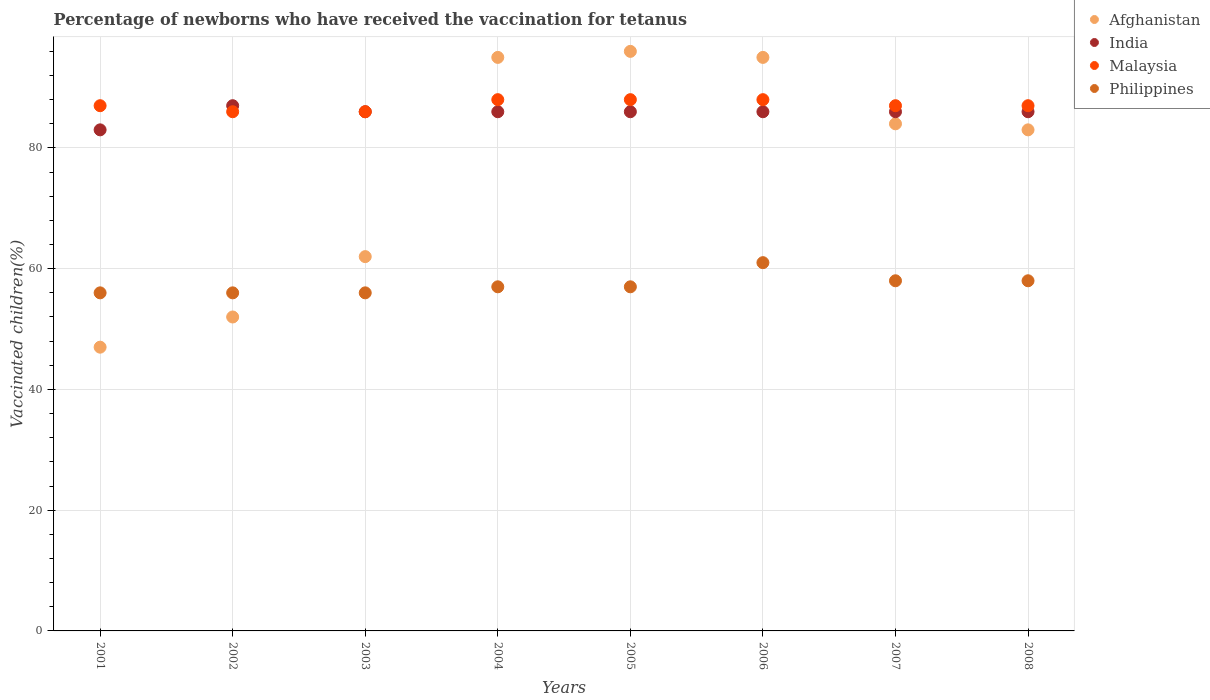Is the number of dotlines equal to the number of legend labels?
Provide a succinct answer. Yes. What is the percentage of vaccinated children in Afghanistan in 2007?
Offer a very short reply. 84. Across all years, what is the maximum percentage of vaccinated children in India?
Make the answer very short. 87. Across all years, what is the minimum percentage of vaccinated children in Philippines?
Ensure brevity in your answer.  56. In which year was the percentage of vaccinated children in India maximum?
Provide a short and direct response. 2002. In which year was the percentage of vaccinated children in Philippines minimum?
Your response must be concise. 2001. What is the total percentage of vaccinated children in Philippines in the graph?
Ensure brevity in your answer.  459. What is the difference between the percentage of vaccinated children in Afghanistan in 2003 and that in 2005?
Make the answer very short. -34. What is the difference between the percentage of vaccinated children in Afghanistan in 2006 and the percentage of vaccinated children in India in 2004?
Your answer should be compact. 9. What is the average percentage of vaccinated children in Afghanistan per year?
Provide a short and direct response. 76.75. In the year 2007, what is the difference between the percentage of vaccinated children in India and percentage of vaccinated children in Malaysia?
Make the answer very short. -1. In how many years, is the percentage of vaccinated children in India greater than 4 %?
Provide a short and direct response. 8. Is the percentage of vaccinated children in India in 2003 less than that in 2004?
Provide a succinct answer. No. What is the difference between the highest and the lowest percentage of vaccinated children in Philippines?
Your answer should be compact. 5. In how many years, is the percentage of vaccinated children in Afghanistan greater than the average percentage of vaccinated children in Afghanistan taken over all years?
Keep it short and to the point. 5. Is it the case that in every year, the sum of the percentage of vaccinated children in India and percentage of vaccinated children in Afghanistan  is greater than the sum of percentage of vaccinated children in Malaysia and percentage of vaccinated children in Philippines?
Keep it short and to the point. No. Is the percentage of vaccinated children in Afghanistan strictly greater than the percentage of vaccinated children in Philippines over the years?
Your answer should be very brief. No. How many dotlines are there?
Your answer should be compact. 4. How many years are there in the graph?
Provide a short and direct response. 8. Are the values on the major ticks of Y-axis written in scientific E-notation?
Give a very brief answer. No. Does the graph contain grids?
Make the answer very short. Yes. Where does the legend appear in the graph?
Keep it short and to the point. Top right. How many legend labels are there?
Offer a very short reply. 4. How are the legend labels stacked?
Your answer should be compact. Vertical. What is the title of the graph?
Ensure brevity in your answer.  Percentage of newborns who have received the vaccination for tetanus. Does "Liechtenstein" appear as one of the legend labels in the graph?
Ensure brevity in your answer.  No. What is the label or title of the Y-axis?
Offer a very short reply. Vaccinated children(%). What is the Vaccinated children(%) of Malaysia in 2001?
Give a very brief answer. 87. What is the Vaccinated children(%) of Afghanistan in 2002?
Give a very brief answer. 52. What is the Vaccinated children(%) in India in 2002?
Provide a short and direct response. 87. What is the Vaccinated children(%) of Malaysia in 2002?
Your answer should be compact. 86. What is the Vaccinated children(%) in Philippines in 2002?
Give a very brief answer. 56. What is the Vaccinated children(%) of India in 2003?
Your answer should be very brief. 86. What is the Vaccinated children(%) in Malaysia in 2003?
Offer a very short reply. 86. What is the Vaccinated children(%) in Malaysia in 2004?
Provide a short and direct response. 88. What is the Vaccinated children(%) of Afghanistan in 2005?
Ensure brevity in your answer.  96. What is the Vaccinated children(%) in Malaysia in 2005?
Give a very brief answer. 88. What is the Vaccinated children(%) of Philippines in 2005?
Offer a very short reply. 57. What is the Vaccinated children(%) of Afghanistan in 2006?
Make the answer very short. 95. What is the Vaccinated children(%) in Malaysia in 2006?
Ensure brevity in your answer.  88. What is the Vaccinated children(%) in India in 2007?
Offer a very short reply. 86. What is the Vaccinated children(%) in Philippines in 2007?
Your response must be concise. 58. What is the Vaccinated children(%) in Afghanistan in 2008?
Give a very brief answer. 83. What is the Vaccinated children(%) of Malaysia in 2008?
Provide a succinct answer. 87. What is the Vaccinated children(%) in Philippines in 2008?
Your response must be concise. 58. Across all years, what is the maximum Vaccinated children(%) in Afghanistan?
Your response must be concise. 96. Across all years, what is the minimum Vaccinated children(%) of Afghanistan?
Ensure brevity in your answer.  47. Across all years, what is the minimum Vaccinated children(%) of India?
Ensure brevity in your answer.  83. Across all years, what is the minimum Vaccinated children(%) in Philippines?
Offer a terse response. 56. What is the total Vaccinated children(%) in Afghanistan in the graph?
Provide a succinct answer. 614. What is the total Vaccinated children(%) in India in the graph?
Your answer should be compact. 686. What is the total Vaccinated children(%) of Malaysia in the graph?
Make the answer very short. 697. What is the total Vaccinated children(%) in Philippines in the graph?
Give a very brief answer. 459. What is the difference between the Vaccinated children(%) of Philippines in 2001 and that in 2002?
Your answer should be very brief. 0. What is the difference between the Vaccinated children(%) of India in 2001 and that in 2003?
Offer a very short reply. -3. What is the difference between the Vaccinated children(%) in Malaysia in 2001 and that in 2003?
Make the answer very short. 1. What is the difference between the Vaccinated children(%) of Philippines in 2001 and that in 2003?
Ensure brevity in your answer.  0. What is the difference between the Vaccinated children(%) of Afghanistan in 2001 and that in 2004?
Ensure brevity in your answer.  -48. What is the difference between the Vaccinated children(%) of Malaysia in 2001 and that in 2004?
Your answer should be very brief. -1. What is the difference between the Vaccinated children(%) in Afghanistan in 2001 and that in 2005?
Offer a terse response. -49. What is the difference between the Vaccinated children(%) of Malaysia in 2001 and that in 2005?
Give a very brief answer. -1. What is the difference between the Vaccinated children(%) of Philippines in 2001 and that in 2005?
Ensure brevity in your answer.  -1. What is the difference between the Vaccinated children(%) in Afghanistan in 2001 and that in 2006?
Provide a short and direct response. -48. What is the difference between the Vaccinated children(%) in Afghanistan in 2001 and that in 2007?
Provide a short and direct response. -37. What is the difference between the Vaccinated children(%) in India in 2001 and that in 2007?
Provide a short and direct response. -3. What is the difference between the Vaccinated children(%) of Malaysia in 2001 and that in 2007?
Ensure brevity in your answer.  0. What is the difference between the Vaccinated children(%) in Afghanistan in 2001 and that in 2008?
Keep it short and to the point. -36. What is the difference between the Vaccinated children(%) in India in 2001 and that in 2008?
Your response must be concise. -3. What is the difference between the Vaccinated children(%) of India in 2002 and that in 2003?
Offer a terse response. 1. What is the difference between the Vaccinated children(%) in Malaysia in 2002 and that in 2003?
Provide a short and direct response. 0. What is the difference between the Vaccinated children(%) in Philippines in 2002 and that in 2003?
Give a very brief answer. 0. What is the difference between the Vaccinated children(%) of Afghanistan in 2002 and that in 2004?
Your response must be concise. -43. What is the difference between the Vaccinated children(%) in India in 2002 and that in 2004?
Your answer should be very brief. 1. What is the difference between the Vaccinated children(%) of Malaysia in 2002 and that in 2004?
Offer a terse response. -2. What is the difference between the Vaccinated children(%) in Philippines in 2002 and that in 2004?
Provide a short and direct response. -1. What is the difference between the Vaccinated children(%) in Afghanistan in 2002 and that in 2005?
Your answer should be compact. -44. What is the difference between the Vaccinated children(%) of India in 2002 and that in 2005?
Give a very brief answer. 1. What is the difference between the Vaccinated children(%) in Afghanistan in 2002 and that in 2006?
Your response must be concise. -43. What is the difference between the Vaccinated children(%) in India in 2002 and that in 2006?
Provide a succinct answer. 1. What is the difference between the Vaccinated children(%) in Malaysia in 2002 and that in 2006?
Your answer should be compact. -2. What is the difference between the Vaccinated children(%) of Afghanistan in 2002 and that in 2007?
Your answer should be compact. -32. What is the difference between the Vaccinated children(%) in India in 2002 and that in 2007?
Keep it short and to the point. 1. What is the difference between the Vaccinated children(%) in Afghanistan in 2002 and that in 2008?
Make the answer very short. -31. What is the difference between the Vaccinated children(%) in India in 2002 and that in 2008?
Offer a very short reply. 1. What is the difference between the Vaccinated children(%) in Afghanistan in 2003 and that in 2004?
Make the answer very short. -33. What is the difference between the Vaccinated children(%) of Philippines in 2003 and that in 2004?
Give a very brief answer. -1. What is the difference between the Vaccinated children(%) in Afghanistan in 2003 and that in 2005?
Provide a short and direct response. -34. What is the difference between the Vaccinated children(%) in Malaysia in 2003 and that in 2005?
Ensure brevity in your answer.  -2. What is the difference between the Vaccinated children(%) of Afghanistan in 2003 and that in 2006?
Your response must be concise. -33. What is the difference between the Vaccinated children(%) in Malaysia in 2003 and that in 2006?
Give a very brief answer. -2. What is the difference between the Vaccinated children(%) of Philippines in 2003 and that in 2006?
Provide a succinct answer. -5. What is the difference between the Vaccinated children(%) of India in 2003 and that in 2007?
Offer a very short reply. 0. What is the difference between the Vaccinated children(%) of Malaysia in 2003 and that in 2007?
Your response must be concise. -1. What is the difference between the Vaccinated children(%) of Philippines in 2003 and that in 2007?
Keep it short and to the point. -2. What is the difference between the Vaccinated children(%) of Afghanistan in 2003 and that in 2008?
Make the answer very short. -21. What is the difference between the Vaccinated children(%) of Philippines in 2003 and that in 2008?
Ensure brevity in your answer.  -2. What is the difference between the Vaccinated children(%) of Malaysia in 2004 and that in 2005?
Offer a terse response. 0. What is the difference between the Vaccinated children(%) of India in 2004 and that in 2006?
Offer a terse response. 0. What is the difference between the Vaccinated children(%) of Afghanistan in 2004 and that in 2007?
Your answer should be compact. 11. What is the difference between the Vaccinated children(%) of Malaysia in 2004 and that in 2007?
Provide a succinct answer. 1. What is the difference between the Vaccinated children(%) of Philippines in 2004 and that in 2007?
Provide a short and direct response. -1. What is the difference between the Vaccinated children(%) of Afghanistan in 2004 and that in 2008?
Make the answer very short. 12. What is the difference between the Vaccinated children(%) in India in 2004 and that in 2008?
Offer a terse response. 0. What is the difference between the Vaccinated children(%) in Philippines in 2004 and that in 2008?
Provide a short and direct response. -1. What is the difference between the Vaccinated children(%) of India in 2005 and that in 2006?
Offer a terse response. 0. What is the difference between the Vaccinated children(%) in Malaysia in 2005 and that in 2006?
Keep it short and to the point. 0. What is the difference between the Vaccinated children(%) of Afghanistan in 2005 and that in 2007?
Keep it short and to the point. 12. What is the difference between the Vaccinated children(%) in India in 2005 and that in 2007?
Offer a very short reply. 0. What is the difference between the Vaccinated children(%) in Philippines in 2005 and that in 2007?
Your response must be concise. -1. What is the difference between the Vaccinated children(%) in Afghanistan in 2005 and that in 2008?
Your response must be concise. 13. What is the difference between the Vaccinated children(%) of India in 2005 and that in 2008?
Ensure brevity in your answer.  0. What is the difference between the Vaccinated children(%) of Malaysia in 2005 and that in 2008?
Offer a terse response. 1. What is the difference between the Vaccinated children(%) of Afghanistan in 2006 and that in 2008?
Give a very brief answer. 12. What is the difference between the Vaccinated children(%) in India in 2006 and that in 2008?
Your answer should be very brief. 0. What is the difference between the Vaccinated children(%) in Malaysia in 2006 and that in 2008?
Ensure brevity in your answer.  1. What is the difference between the Vaccinated children(%) in Philippines in 2006 and that in 2008?
Your answer should be very brief. 3. What is the difference between the Vaccinated children(%) in Afghanistan in 2007 and that in 2008?
Make the answer very short. 1. What is the difference between the Vaccinated children(%) of India in 2007 and that in 2008?
Your response must be concise. 0. What is the difference between the Vaccinated children(%) in Malaysia in 2007 and that in 2008?
Ensure brevity in your answer.  0. What is the difference between the Vaccinated children(%) of Philippines in 2007 and that in 2008?
Your answer should be compact. 0. What is the difference between the Vaccinated children(%) of Afghanistan in 2001 and the Vaccinated children(%) of Malaysia in 2002?
Provide a succinct answer. -39. What is the difference between the Vaccinated children(%) of Afghanistan in 2001 and the Vaccinated children(%) of Philippines in 2002?
Keep it short and to the point. -9. What is the difference between the Vaccinated children(%) of Afghanistan in 2001 and the Vaccinated children(%) of India in 2003?
Offer a very short reply. -39. What is the difference between the Vaccinated children(%) in Afghanistan in 2001 and the Vaccinated children(%) in Malaysia in 2003?
Keep it short and to the point. -39. What is the difference between the Vaccinated children(%) in Afghanistan in 2001 and the Vaccinated children(%) in Philippines in 2003?
Ensure brevity in your answer.  -9. What is the difference between the Vaccinated children(%) in India in 2001 and the Vaccinated children(%) in Malaysia in 2003?
Give a very brief answer. -3. What is the difference between the Vaccinated children(%) in Malaysia in 2001 and the Vaccinated children(%) in Philippines in 2003?
Provide a succinct answer. 31. What is the difference between the Vaccinated children(%) in Afghanistan in 2001 and the Vaccinated children(%) in India in 2004?
Provide a succinct answer. -39. What is the difference between the Vaccinated children(%) in Afghanistan in 2001 and the Vaccinated children(%) in Malaysia in 2004?
Offer a very short reply. -41. What is the difference between the Vaccinated children(%) in Afghanistan in 2001 and the Vaccinated children(%) in Philippines in 2004?
Offer a very short reply. -10. What is the difference between the Vaccinated children(%) of India in 2001 and the Vaccinated children(%) of Malaysia in 2004?
Make the answer very short. -5. What is the difference between the Vaccinated children(%) in India in 2001 and the Vaccinated children(%) in Philippines in 2004?
Make the answer very short. 26. What is the difference between the Vaccinated children(%) in Afghanistan in 2001 and the Vaccinated children(%) in India in 2005?
Ensure brevity in your answer.  -39. What is the difference between the Vaccinated children(%) in Afghanistan in 2001 and the Vaccinated children(%) in Malaysia in 2005?
Ensure brevity in your answer.  -41. What is the difference between the Vaccinated children(%) in Malaysia in 2001 and the Vaccinated children(%) in Philippines in 2005?
Your answer should be compact. 30. What is the difference between the Vaccinated children(%) of Afghanistan in 2001 and the Vaccinated children(%) of India in 2006?
Provide a short and direct response. -39. What is the difference between the Vaccinated children(%) in Afghanistan in 2001 and the Vaccinated children(%) in Malaysia in 2006?
Give a very brief answer. -41. What is the difference between the Vaccinated children(%) of India in 2001 and the Vaccinated children(%) of Philippines in 2006?
Ensure brevity in your answer.  22. What is the difference between the Vaccinated children(%) of Afghanistan in 2001 and the Vaccinated children(%) of India in 2007?
Ensure brevity in your answer.  -39. What is the difference between the Vaccinated children(%) of Malaysia in 2001 and the Vaccinated children(%) of Philippines in 2007?
Your response must be concise. 29. What is the difference between the Vaccinated children(%) in Afghanistan in 2001 and the Vaccinated children(%) in India in 2008?
Your answer should be compact. -39. What is the difference between the Vaccinated children(%) of Afghanistan in 2001 and the Vaccinated children(%) of Malaysia in 2008?
Make the answer very short. -40. What is the difference between the Vaccinated children(%) of Afghanistan in 2001 and the Vaccinated children(%) of Philippines in 2008?
Offer a very short reply. -11. What is the difference between the Vaccinated children(%) of India in 2001 and the Vaccinated children(%) of Philippines in 2008?
Offer a terse response. 25. What is the difference between the Vaccinated children(%) in Malaysia in 2001 and the Vaccinated children(%) in Philippines in 2008?
Give a very brief answer. 29. What is the difference between the Vaccinated children(%) of Afghanistan in 2002 and the Vaccinated children(%) of India in 2003?
Offer a terse response. -34. What is the difference between the Vaccinated children(%) of Afghanistan in 2002 and the Vaccinated children(%) of Malaysia in 2003?
Your answer should be very brief. -34. What is the difference between the Vaccinated children(%) of Afghanistan in 2002 and the Vaccinated children(%) of Philippines in 2003?
Offer a very short reply. -4. What is the difference between the Vaccinated children(%) of India in 2002 and the Vaccinated children(%) of Philippines in 2003?
Ensure brevity in your answer.  31. What is the difference between the Vaccinated children(%) in Afghanistan in 2002 and the Vaccinated children(%) in India in 2004?
Keep it short and to the point. -34. What is the difference between the Vaccinated children(%) of Afghanistan in 2002 and the Vaccinated children(%) of Malaysia in 2004?
Your answer should be very brief. -36. What is the difference between the Vaccinated children(%) of India in 2002 and the Vaccinated children(%) of Malaysia in 2004?
Keep it short and to the point. -1. What is the difference between the Vaccinated children(%) in Malaysia in 2002 and the Vaccinated children(%) in Philippines in 2004?
Provide a short and direct response. 29. What is the difference between the Vaccinated children(%) of Afghanistan in 2002 and the Vaccinated children(%) of India in 2005?
Provide a short and direct response. -34. What is the difference between the Vaccinated children(%) in Afghanistan in 2002 and the Vaccinated children(%) in Malaysia in 2005?
Your answer should be very brief. -36. What is the difference between the Vaccinated children(%) of India in 2002 and the Vaccinated children(%) of Malaysia in 2005?
Offer a very short reply. -1. What is the difference between the Vaccinated children(%) in India in 2002 and the Vaccinated children(%) in Philippines in 2005?
Provide a short and direct response. 30. What is the difference between the Vaccinated children(%) in Afghanistan in 2002 and the Vaccinated children(%) in India in 2006?
Provide a succinct answer. -34. What is the difference between the Vaccinated children(%) of Afghanistan in 2002 and the Vaccinated children(%) of Malaysia in 2006?
Make the answer very short. -36. What is the difference between the Vaccinated children(%) of Afghanistan in 2002 and the Vaccinated children(%) of India in 2007?
Offer a very short reply. -34. What is the difference between the Vaccinated children(%) of Afghanistan in 2002 and the Vaccinated children(%) of Malaysia in 2007?
Your answer should be compact. -35. What is the difference between the Vaccinated children(%) in Afghanistan in 2002 and the Vaccinated children(%) in Philippines in 2007?
Provide a short and direct response. -6. What is the difference between the Vaccinated children(%) of Malaysia in 2002 and the Vaccinated children(%) of Philippines in 2007?
Make the answer very short. 28. What is the difference between the Vaccinated children(%) of Afghanistan in 2002 and the Vaccinated children(%) of India in 2008?
Make the answer very short. -34. What is the difference between the Vaccinated children(%) of Afghanistan in 2002 and the Vaccinated children(%) of Malaysia in 2008?
Your answer should be compact. -35. What is the difference between the Vaccinated children(%) in India in 2002 and the Vaccinated children(%) in Malaysia in 2008?
Provide a succinct answer. 0. What is the difference between the Vaccinated children(%) of India in 2002 and the Vaccinated children(%) of Philippines in 2008?
Ensure brevity in your answer.  29. What is the difference between the Vaccinated children(%) in Afghanistan in 2003 and the Vaccinated children(%) in Philippines in 2004?
Ensure brevity in your answer.  5. What is the difference between the Vaccinated children(%) of Afghanistan in 2003 and the Vaccinated children(%) of Malaysia in 2005?
Offer a terse response. -26. What is the difference between the Vaccinated children(%) in Afghanistan in 2003 and the Vaccinated children(%) in Philippines in 2005?
Offer a terse response. 5. What is the difference between the Vaccinated children(%) in India in 2003 and the Vaccinated children(%) in Philippines in 2005?
Keep it short and to the point. 29. What is the difference between the Vaccinated children(%) in Afghanistan in 2003 and the Vaccinated children(%) in Malaysia in 2006?
Provide a succinct answer. -26. What is the difference between the Vaccinated children(%) in Afghanistan in 2003 and the Vaccinated children(%) in Philippines in 2007?
Provide a short and direct response. 4. What is the difference between the Vaccinated children(%) of India in 2003 and the Vaccinated children(%) of Malaysia in 2007?
Provide a succinct answer. -1. What is the difference between the Vaccinated children(%) of Afghanistan in 2003 and the Vaccinated children(%) of India in 2008?
Keep it short and to the point. -24. What is the difference between the Vaccinated children(%) in Afghanistan in 2003 and the Vaccinated children(%) in Philippines in 2008?
Provide a short and direct response. 4. What is the difference between the Vaccinated children(%) in India in 2003 and the Vaccinated children(%) in Philippines in 2008?
Keep it short and to the point. 28. What is the difference between the Vaccinated children(%) of Malaysia in 2003 and the Vaccinated children(%) of Philippines in 2008?
Your answer should be very brief. 28. What is the difference between the Vaccinated children(%) in Afghanistan in 2004 and the Vaccinated children(%) in India in 2005?
Your answer should be compact. 9. What is the difference between the Vaccinated children(%) of Afghanistan in 2004 and the Vaccinated children(%) of Philippines in 2005?
Your answer should be very brief. 38. What is the difference between the Vaccinated children(%) of India in 2004 and the Vaccinated children(%) of Malaysia in 2005?
Keep it short and to the point. -2. What is the difference between the Vaccinated children(%) of India in 2004 and the Vaccinated children(%) of Philippines in 2005?
Offer a terse response. 29. What is the difference between the Vaccinated children(%) of Malaysia in 2004 and the Vaccinated children(%) of Philippines in 2005?
Ensure brevity in your answer.  31. What is the difference between the Vaccinated children(%) of Afghanistan in 2004 and the Vaccinated children(%) of India in 2006?
Your response must be concise. 9. What is the difference between the Vaccinated children(%) in Afghanistan in 2004 and the Vaccinated children(%) in Malaysia in 2006?
Your answer should be compact. 7. What is the difference between the Vaccinated children(%) of India in 2004 and the Vaccinated children(%) of Malaysia in 2006?
Keep it short and to the point. -2. What is the difference between the Vaccinated children(%) in Afghanistan in 2004 and the Vaccinated children(%) in India in 2007?
Your answer should be very brief. 9. What is the difference between the Vaccinated children(%) in Afghanistan in 2004 and the Vaccinated children(%) in Malaysia in 2007?
Provide a short and direct response. 8. What is the difference between the Vaccinated children(%) in Afghanistan in 2004 and the Vaccinated children(%) in Malaysia in 2008?
Your answer should be compact. 8. What is the difference between the Vaccinated children(%) of India in 2004 and the Vaccinated children(%) of Malaysia in 2008?
Offer a very short reply. -1. What is the difference between the Vaccinated children(%) in Malaysia in 2004 and the Vaccinated children(%) in Philippines in 2008?
Offer a terse response. 30. What is the difference between the Vaccinated children(%) in Afghanistan in 2005 and the Vaccinated children(%) in Malaysia in 2006?
Offer a very short reply. 8. What is the difference between the Vaccinated children(%) in Afghanistan in 2005 and the Vaccinated children(%) in Philippines in 2006?
Provide a short and direct response. 35. What is the difference between the Vaccinated children(%) of India in 2005 and the Vaccinated children(%) of Malaysia in 2006?
Make the answer very short. -2. What is the difference between the Vaccinated children(%) of India in 2005 and the Vaccinated children(%) of Philippines in 2006?
Make the answer very short. 25. What is the difference between the Vaccinated children(%) of Afghanistan in 2005 and the Vaccinated children(%) of India in 2007?
Give a very brief answer. 10. What is the difference between the Vaccinated children(%) in Afghanistan in 2005 and the Vaccinated children(%) in Malaysia in 2007?
Provide a succinct answer. 9. What is the difference between the Vaccinated children(%) in India in 2005 and the Vaccinated children(%) in Malaysia in 2007?
Keep it short and to the point. -1. What is the difference between the Vaccinated children(%) in Malaysia in 2005 and the Vaccinated children(%) in Philippines in 2007?
Offer a very short reply. 30. What is the difference between the Vaccinated children(%) in Afghanistan in 2005 and the Vaccinated children(%) in Malaysia in 2008?
Offer a very short reply. 9. What is the difference between the Vaccinated children(%) of Afghanistan in 2005 and the Vaccinated children(%) of Philippines in 2008?
Make the answer very short. 38. What is the difference between the Vaccinated children(%) in Afghanistan in 2006 and the Vaccinated children(%) in India in 2007?
Ensure brevity in your answer.  9. What is the difference between the Vaccinated children(%) of Afghanistan in 2006 and the Vaccinated children(%) of Malaysia in 2007?
Your answer should be very brief. 8. What is the difference between the Vaccinated children(%) of Afghanistan in 2006 and the Vaccinated children(%) of India in 2008?
Keep it short and to the point. 9. What is the difference between the Vaccinated children(%) of Afghanistan in 2006 and the Vaccinated children(%) of Philippines in 2008?
Offer a very short reply. 37. What is the difference between the Vaccinated children(%) in India in 2006 and the Vaccinated children(%) in Malaysia in 2008?
Provide a succinct answer. -1. What is the difference between the Vaccinated children(%) in Malaysia in 2006 and the Vaccinated children(%) in Philippines in 2008?
Your answer should be very brief. 30. What is the difference between the Vaccinated children(%) of Afghanistan in 2007 and the Vaccinated children(%) of Malaysia in 2008?
Offer a very short reply. -3. What is the difference between the Vaccinated children(%) of Afghanistan in 2007 and the Vaccinated children(%) of Philippines in 2008?
Offer a terse response. 26. What is the difference between the Vaccinated children(%) in Malaysia in 2007 and the Vaccinated children(%) in Philippines in 2008?
Your answer should be very brief. 29. What is the average Vaccinated children(%) in Afghanistan per year?
Your answer should be compact. 76.75. What is the average Vaccinated children(%) in India per year?
Provide a short and direct response. 85.75. What is the average Vaccinated children(%) of Malaysia per year?
Your answer should be very brief. 87.12. What is the average Vaccinated children(%) in Philippines per year?
Ensure brevity in your answer.  57.38. In the year 2001, what is the difference between the Vaccinated children(%) of Afghanistan and Vaccinated children(%) of India?
Ensure brevity in your answer.  -36. In the year 2001, what is the difference between the Vaccinated children(%) in India and Vaccinated children(%) in Malaysia?
Make the answer very short. -4. In the year 2001, what is the difference between the Vaccinated children(%) in India and Vaccinated children(%) in Philippines?
Make the answer very short. 27. In the year 2002, what is the difference between the Vaccinated children(%) in Afghanistan and Vaccinated children(%) in India?
Make the answer very short. -35. In the year 2002, what is the difference between the Vaccinated children(%) of Afghanistan and Vaccinated children(%) of Malaysia?
Provide a succinct answer. -34. In the year 2002, what is the difference between the Vaccinated children(%) in India and Vaccinated children(%) in Malaysia?
Provide a succinct answer. 1. In the year 2003, what is the difference between the Vaccinated children(%) of India and Vaccinated children(%) of Philippines?
Your answer should be very brief. 30. In the year 2004, what is the difference between the Vaccinated children(%) in Malaysia and Vaccinated children(%) in Philippines?
Your answer should be compact. 31. In the year 2005, what is the difference between the Vaccinated children(%) in Afghanistan and Vaccinated children(%) in Malaysia?
Provide a succinct answer. 8. In the year 2005, what is the difference between the Vaccinated children(%) in Afghanistan and Vaccinated children(%) in Philippines?
Make the answer very short. 39. In the year 2005, what is the difference between the Vaccinated children(%) of India and Vaccinated children(%) of Malaysia?
Provide a short and direct response. -2. In the year 2005, what is the difference between the Vaccinated children(%) in India and Vaccinated children(%) in Philippines?
Ensure brevity in your answer.  29. In the year 2006, what is the difference between the Vaccinated children(%) in Afghanistan and Vaccinated children(%) in Malaysia?
Your response must be concise. 7. In the year 2006, what is the difference between the Vaccinated children(%) of India and Vaccinated children(%) of Malaysia?
Your answer should be compact. -2. In the year 2007, what is the difference between the Vaccinated children(%) of Afghanistan and Vaccinated children(%) of Malaysia?
Provide a short and direct response. -3. In the year 2007, what is the difference between the Vaccinated children(%) in India and Vaccinated children(%) in Philippines?
Your response must be concise. 28. In the year 2008, what is the difference between the Vaccinated children(%) in Afghanistan and Vaccinated children(%) in India?
Make the answer very short. -3. In the year 2008, what is the difference between the Vaccinated children(%) in Afghanistan and Vaccinated children(%) in Malaysia?
Offer a terse response. -4. In the year 2008, what is the difference between the Vaccinated children(%) in India and Vaccinated children(%) in Philippines?
Offer a very short reply. 28. In the year 2008, what is the difference between the Vaccinated children(%) in Malaysia and Vaccinated children(%) in Philippines?
Provide a succinct answer. 29. What is the ratio of the Vaccinated children(%) of Afghanistan in 2001 to that in 2002?
Provide a short and direct response. 0.9. What is the ratio of the Vaccinated children(%) of India in 2001 to that in 2002?
Keep it short and to the point. 0.95. What is the ratio of the Vaccinated children(%) of Malaysia in 2001 to that in 2002?
Ensure brevity in your answer.  1.01. What is the ratio of the Vaccinated children(%) in Philippines in 2001 to that in 2002?
Your answer should be very brief. 1. What is the ratio of the Vaccinated children(%) in Afghanistan in 2001 to that in 2003?
Ensure brevity in your answer.  0.76. What is the ratio of the Vaccinated children(%) of India in 2001 to that in 2003?
Your answer should be very brief. 0.97. What is the ratio of the Vaccinated children(%) of Malaysia in 2001 to that in 2003?
Ensure brevity in your answer.  1.01. What is the ratio of the Vaccinated children(%) in Afghanistan in 2001 to that in 2004?
Provide a succinct answer. 0.49. What is the ratio of the Vaccinated children(%) in India in 2001 to that in 2004?
Offer a very short reply. 0.97. What is the ratio of the Vaccinated children(%) in Malaysia in 2001 to that in 2004?
Keep it short and to the point. 0.99. What is the ratio of the Vaccinated children(%) in Philippines in 2001 to that in 2004?
Keep it short and to the point. 0.98. What is the ratio of the Vaccinated children(%) of Afghanistan in 2001 to that in 2005?
Your answer should be very brief. 0.49. What is the ratio of the Vaccinated children(%) of India in 2001 to that in 2005?
Give a very brief answer. 0.97. What is the ratio of the Vaccinated children(%) of Philippines in 2001 to that in 2005?
Provide a short and direct response. 0.98. What is the ratio of the Vaccinated children(%) of Afghanistan in 2001 to that in 2006?
Keep it short and to the point. 0.49. What is the ratio of the Vaccinated children(%) in India in 2001 to that in 2006?
Your answer should be very brief. 0.97. What is the ratio of the Vaccinated children(%) in Philippines in 2001 to that in 2006?
Ensure brevity in your answer.  0.92. What is the ratio of the Vaccinated children(%) of Afghanistan in 2001 to that in 2007?
Ensure brevity in your answer.  0.56. What is the ratio of the Vaccinated children(%) in India in 2001 to that in 2007?
Ensure brevity in your answer.  0.97. What is the ratio of the Vaccinated children(%) in Malaysia in 2001 to that in 2007?
Your answer should be very brief. 1. What is the ratio of the Vaccinated children(%) of Philippines in 2001 to that in 2007?
Your answer should be very brief. 0.97. What is the ratio of the Vaccinated children(%) in Afghanistan in 2001 to that in 2008?
Offer a very short reply. 0.57. What is the ratio of the Vaccinated children(%) in India in 2001 to that in 2008?
Keep it short and to the point. 0.97. What is the ratio of the Vaccinated children(%) in Malaysia in 2001 to that in 2008?
Your answer should be very brief. 1. What is the ratio of the Vaccinated children(%) in Philippines in 2001 to that in 2008?
Offer a very short reply. 0.97. What is the ratio of the Vaccinated children(%) of Afghanistan in 2002 to that in 2003?
Offer a very short reply. 0.84. What is the ratio of the Vaccinated children(%) in India in 2002 to that in 2003?
Your answer should be compact. 1.01. What is the ratio of the Vaccinated children(%) in Malaysia in 2002 to that in 2003?
Keep it short and to the point. 1. What is the ratio of the Vaccinated children(%) of Philippines in 2002 to that in 2003?
Provide a short and direct response. 1. What is the ratio of the Vaccinated children(%) of Afghanistan in 2002 to that in 2004?
Keep it short and to the point. 0.55. What is the ratio of the Vaccinated children(%) of India in 2002 to that in 2004?
Offer a terse response. 1.01. What is the ratio of the Vaccinated children(%) in Malaysia in 2002 to that in 2004?
Offer a very short reply. 0.98. What is the ratio of the Vaccinated children(%) of Philippines in 2002 to that in 2004?
Ensure brevity in your answer.  0.98. What is the ratio of the Vaccinated children(%) in Afghanistan in 2002 to that in 2005?
Make the answer very short. 0.54. What is the ratio of the Vaccinated children(%) in India in 2002 to that in 2005?
Provide a succinct answer. 1.01. What is the ratio of the Vaccinated children(%) of Malaysia in 2002 to that in 2005?
Provide a short and direct response. 0.98. What is the ratio of the Vaccinated children(%) in Philippines in 2002 to that in 2005?
Your answer should be compact. 0.98. What is the ratio of the Vaccinated children(%) in Afghanistan in 2002 to that in 2006?
Keep it short and to the point. 0.55. What is the ratio of the Vaccinated children(%) in India in 2002 to that in 2006?
Keep it short and to the point. 1.01. What is the ratio of the Vaccinated children(%) of Malaysia in 2002 to that in 2006?
Give a very brief answer. 0.98. What is the ratio of the Vaccinated children(%) in Philippines in 2002 to that in 2006?
Your response must be concise. 0.92. What is the ratio of the Vaccinated children(%) in Afghanistan in 2002 to that in 2007?
Give a very brief answer. 0.62. What is the ratio of the Vaccinated children(%) in India in 2002 to that in 2007?
Offer a very short reply. 1.01. What is the ratio of the Vaccinated children(%) in Malaysia in 2002 to that in 2007?
Give a very brief answer. 0.99. What is the ratio of the Vaccinated children(%) of Philippines in 2002 to that in 2007?
Your response must be concise. 0.97. What is the ratio of the Vaccinated children(%) of Afghanistan in 2002 to that in 2008?
Your response must be concise. 0.63. What is the ratio of the Vaccinated children(%) in India in 2002 to that in 2008?
Offer a terse response. 1.01. What is the ratio of the Vaccinated children(%) of Malaysia in 2002 to that in 2008?
Give a very brief answer. 0.99. What is the ratio of the Vaccinated children(%) of Philippines in 2002 to that in 2008?
Provide a succinct answer. 0.97. What is the ratio of the Vaccinated children(%) in Afghanistan in 2003 to that in 2004?
Offer a very short reply. 0.65. What is the ratio of the Vaccinated children(%) in India in 2003 to that in 2004?
Offer a terse response. 1. What is the ratio of the Vaccinated children(%) in Malaysia in 2003 to that in 2004?
Make the answer very short. 0.98. What is the ratio of the Vaccinated children(%) of Philippines in 2003 to that in 2004?
Offer a terse response. 0.98. What is the ratio of the Vaccinated children(%) of Afghanistan in 2003 to that in 2005?
Offer a terse response. 0.65. What is the ratio of the Vaccinated children(%) in India in 2003 to that in 2005?
Keep it short and to the point. 1. What is the ratio of the Vaccinated children(%) in Malaysia in 2003 to that in 2005?
Provide a succinct answer. 0.98. What is the ratio of the Vaccinated children(%) of Philippines in 2003 to that in 2005?
Provide a succinct answer. 0.98. What is the ratio of the Vaccinated children(%) of Afghanistan in 2003 to that in 2006?
Your response must be concise. 0.65. What is the ratio of the Vaccinated children(%) in Malaysia in 2003 to that in 2006?
Offer a terse response. 0.98. What is the ratio of the Vaccinated children(%) of Philippines in 2003 to that in 2006?
Your answer should be compact. 0.92. What is the ratio of the Vaccinated children(%) of Afghanistan in 2003 to that in 2007?
Your answer should be compact. 0.74. What is the ratio of the Vaccinated children(%) in India in 2003 to that in 2007?
Make the answer very short. 1. What is the ratio of the Vaccinated children(%) of Malaysia in 2003 to that in 2007?
Ensure brevity in your answer.  0.99. What is the ratio of the Vaccinated children(%) of Philippines in 2003 to that in 2007?
Provide a short and direct response. 0.97. What is the ratio of the Vaccinated children(%) in Afghanistan in 2003 to that in 2008?
Give a very brief answer. 0.75. What is the ratio of the Vaccinated children(%) of Malaysia in 2003 to that in 2008?
Make the answer very short. 0.99. What is the ratio of the Vaccinated children(%) of Philippines in 2003 to that in 2008?
Provide a short and direct response. 0.97. What is the ratio of the Vaccinated children(%) in India in 2004 to that in 2005?
Your response must be concise. 1. What is the ratio of the Vaccinated children(%) of Malaysia in 2004 to that in 2005?
Provide a succinct answer. 1. What is the ratio of the Vaccinated children(%) in Philippines in 2004 to that in 2005?
Offer a terse response. 1. What is the ratio of the Vaccinated children(%) of India in 2004 to that in 2006?
Ensure brevity in your answer.  1. What is the ratio of the Vaccinated children(%) of Philippines in 2004 to that in 2006?
Give a very brief answer. 0.93. What is the ratio of the Vaccinated children(%) of Afghanistan in 2004 to that in 2007?
Give a very brief answer. 1.13. What is the ratio of the Vaccinated children(%) in Malaysia in 2004 to that in 2007?
Ensure brevity in your answer.  1.01. What is the ratio of the Vaccinated children(%) of Philippines in 2004 to that in 2007?
Make the answer very short. 0.98. What is the ratio of the Vaccinated children(%) in Afghanistan in 2004 to that in 2008?
Provide a succinct answer. 1.14. What is the ratio of the Vaccinated children(%) of India in 2004 to that in 2008?
Give a very brief answer. 1. What is the ratio of the Vaccinated children(%) of Malaysia in 2004 to that in 2008?
Ensure brevity in your answer.  1.01. What is the ratio of the Vaccinated children(%) of Philippines in 2004 to that in 2008?
Ensure brevity in your answer.  0.98. What is the ratio of the Vaccinated children(%) of Afghanistan in 2005 to that in 2006?
Provide a short and direct response. 1.01. What is the ratio of the Vaccinated children(%) of India in 2005 to that in 2006?
Your answer should be very brief. 1. What is the ratio of the Vaccinated children(%) in Malaysia in 2005 to that in 2006?
Provide a succinct answer. 1. What is the ratio of the Vaccinated children(%) in Philippines in 2005 to that in 2006?
Your answer should be very brief. 0.93. What is the ratio of the Vaccinated children(%) of Afghanistan in 2005 to that in 2007?
Give a very brief answer. 1.14. What is the ratio of the Vaccinated children(%) in India in 2005 to that in 2007?
Your response must be concise. 1. What is the ratio of the Vaccinated children(%) of Malaysia in 2005 to that in 2007?
Your answer should be very brief. 1.01. What is the ratio of the Vaccinated children(%) in Philippines in 2005 to that in 2007?
Your response must be concise. 0.98. What is the ratio of the Vaccinated children(%) of Afghanistan in 2005 to that in 2008?
Your response must be concise. 1.16. What is the ratio of the Vaccinated children(%) of Malaysia in 2005 to that in 2008?
Your answer should be very brief. 1.01. What is the ratio of the Vaccinated children(%) of Philippines in 2005 to that in 2008?
Your answer should be very brief. 0.98. What is the ratio of the Vaccinated children(%) in Afghanistan in 2006 to that in 2007?
Your answer should be very brief. 1.13. What is the ratio of the Vaccinated children(%) in Malaysia in 2006 to that in 2007?
Provide a succinct answer. 1.01. What is the ratio of the Vaccinated children(%) of Philippines in 2006 to that in 2007?
Your response must be concise. 1.05. What is the ratio of the Vaccinated children(%) of Afghanistan in 2006 to that in 2008?
Ensure brevity in your answer.  1.14. What is the ratio of the Vaccinated children(%) of Malaysia in 2006 to that in 2008?
Your answer should be very brief. 1.01. What is the ratio of the Vaccinated children(%) of Philippines in 2006 to that in 2008?
Ensure brevity in your answer.  1.05. What is the ratio of the Vaccinated children(%) in India in 2007 to that in 2008?
Give a very brief answer. 1. What is the ratio of the Vaccinated children(%) in Malaysia in 2007 to that in 2008?
Ensure brevity in your answer.  1. What is the difference between the highest and the second highest Vaccinated children(%) in Afghanistan?
Keep it short and to the point. 1. What is the difference between the highest and the second highest Vaccinated children(%) in India?
Your response must be concise. 1. What is the difference between the highest and the second highest Vaccinated children(%) of Malaysia?
Offer a very short reply. 0. What is the difference between the highest and the second highest Vaccinated children(%) of Philippines?
Your answer should be compact. 3. What is the difference between the highest and the lowest Vaccinated children(%) of Philippines?
Keep it short and to the point. 5. 